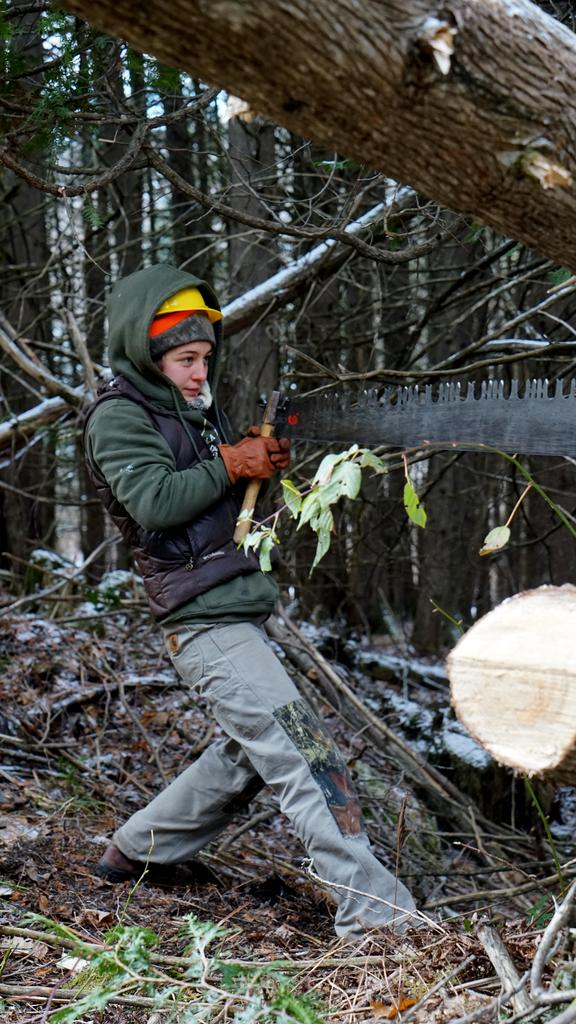What is the main subject of the picture? The main subject of the picture is a kid. What is the kid standing on? The kid is standing on dry leaves. What can be seen in the background of the picture? There are tall trees around the kid. What other object is present in the image? There is a wooden log in the image. What type of rifle is the kid holding in the picture? There is no rifle present in the image; the kid is not holding any weapon. 